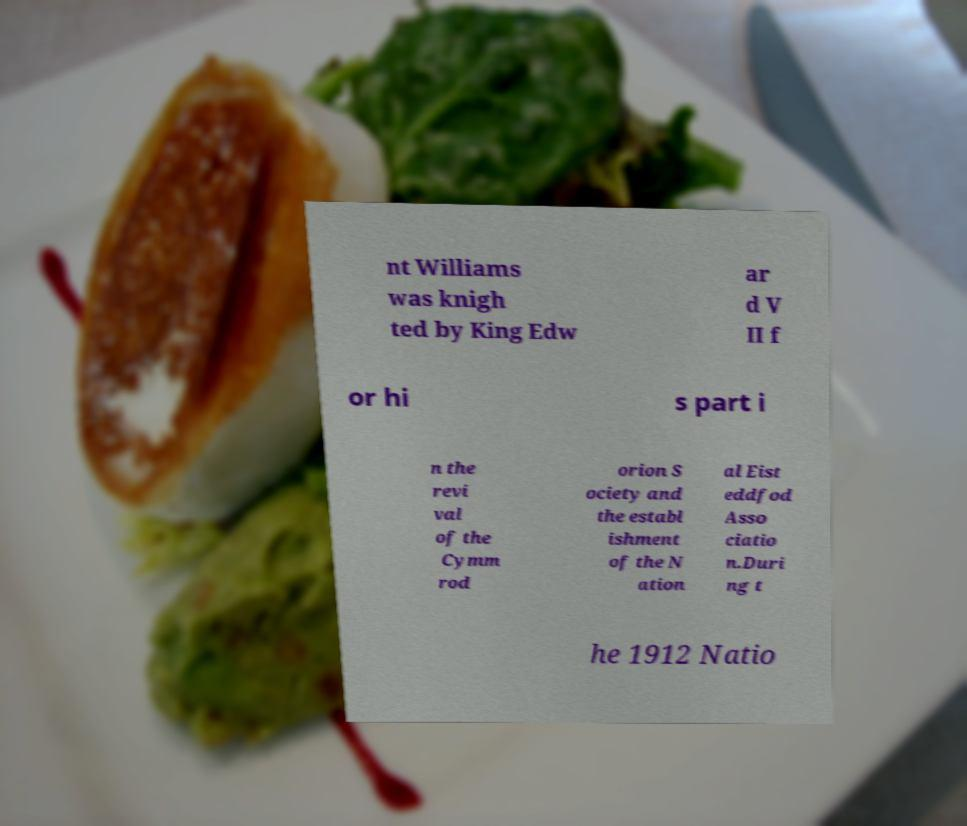Can you read and provide the text displayed in the image?This photo seems to have some interesting text. Can you extract and type it out for me? nt Williams was knigh ted by King Edw ar d V II f or hi s part i n the revi val of the Cymm rod orion S ociety and the establ ishment of the N ation al Eist eddfod Asso ciatio n.Duri ng t he 1912 Natio 